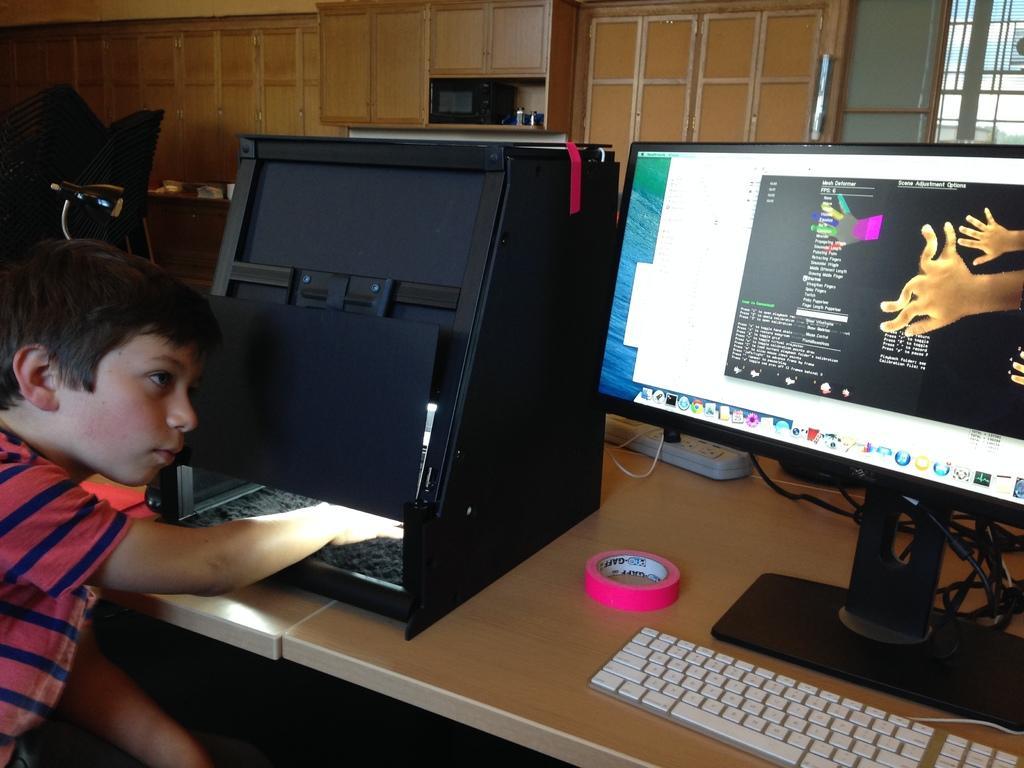Describe this image in one or two sentences. The picture is clicked on a desk where there is a monitor, keyboard and a kid is placing his hand inside a black box , in the background we observe a wooden shelf , glass window. There is also a tape on the table. 